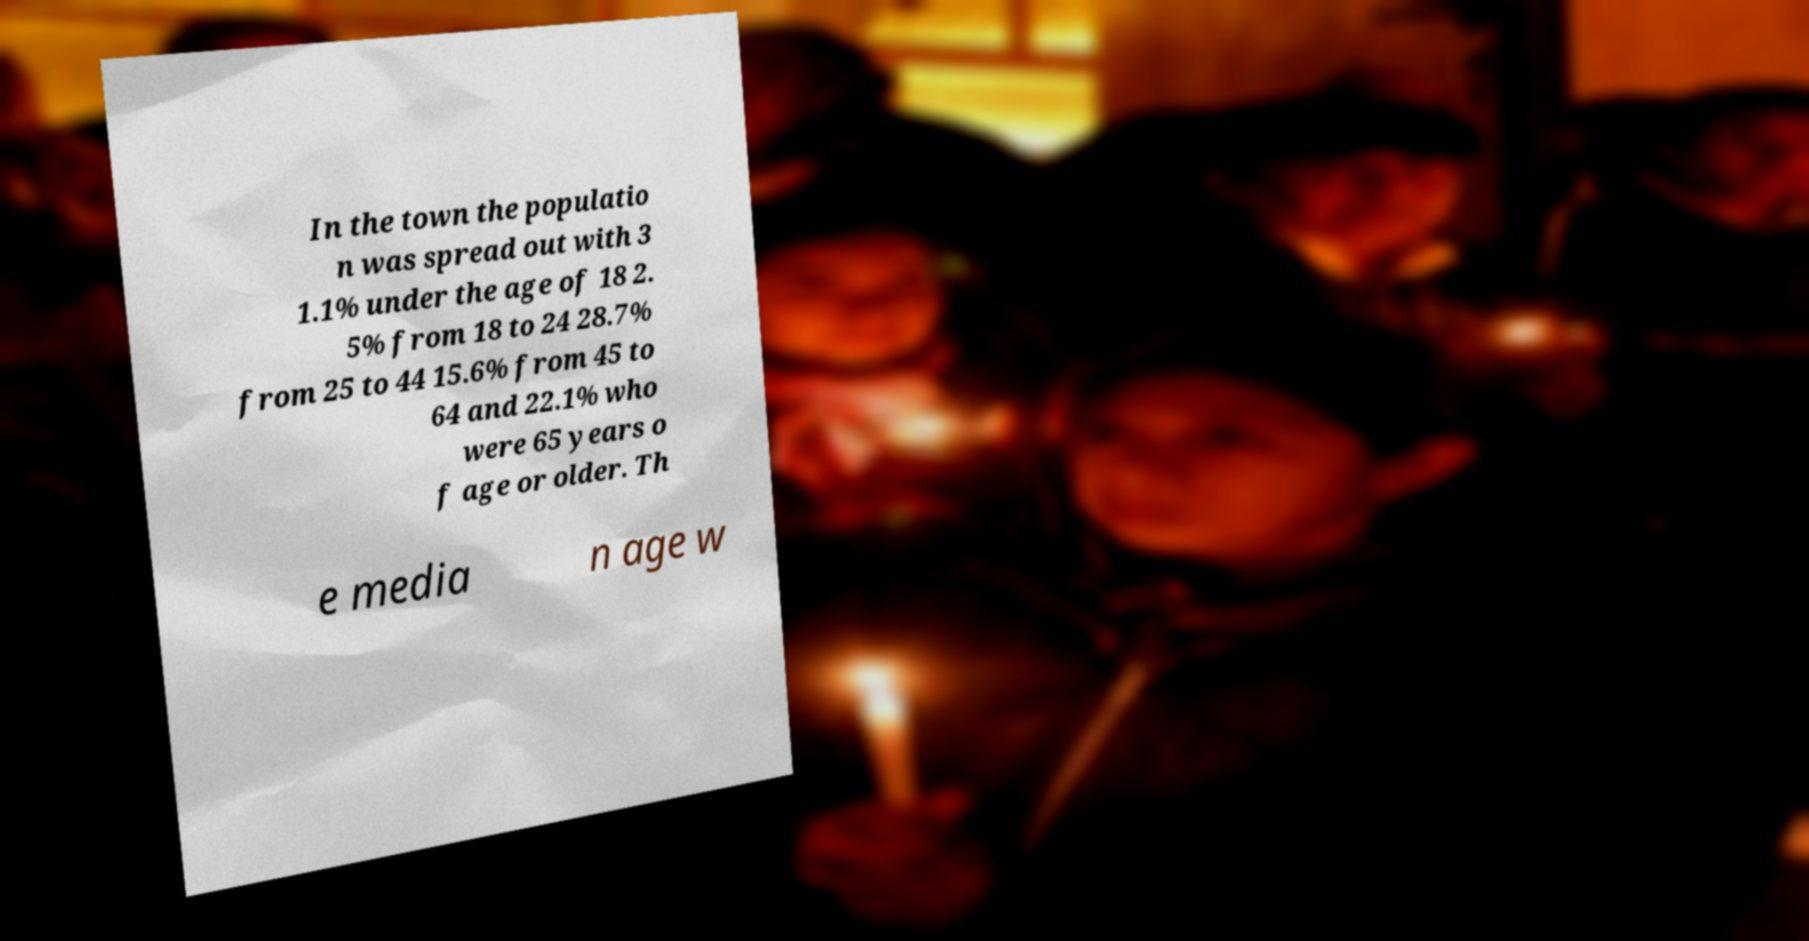I need the written content from this picture converted into text. Can you do that? In the town the populatio n was spread out with 3 1.1% under the age of 18 2. 5% from 18 to 24 28.7% from 25 to 44 15.6% from 45 to 64 and 22.1% who were 65 years o f age or older. Th e media n age w 